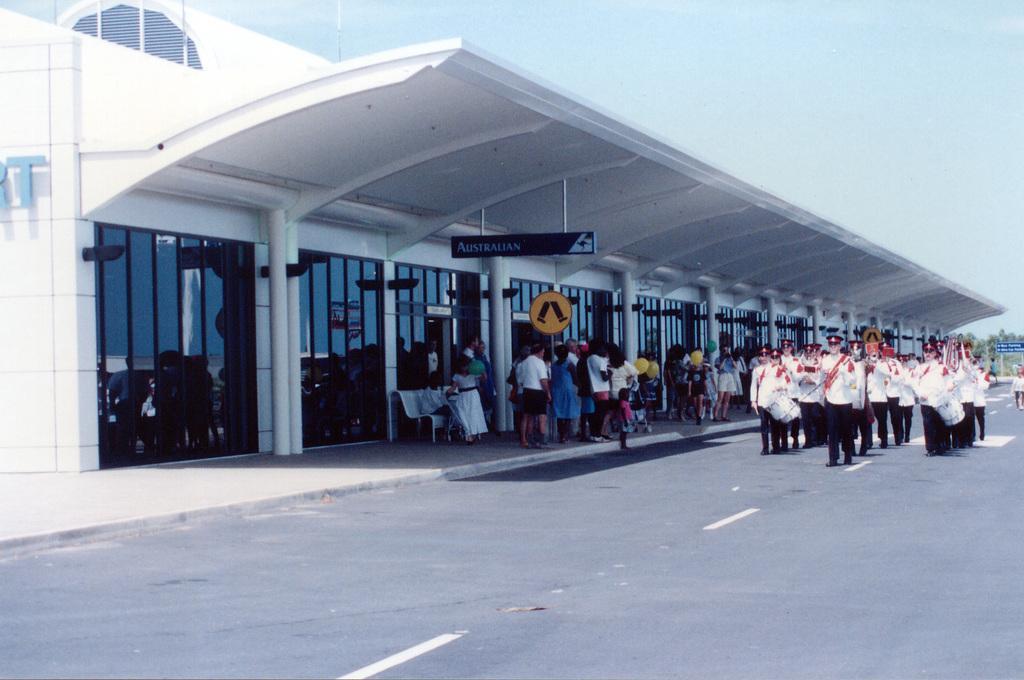Could you give a brief overview of what you see in this image? On the right side, there are persons in white color shirts, walking on the road, on which there are white color lines. Some of these persons are playing musical instruments. Beside this road, there are persons on the platform, which is having a roof attached to a building, which is having glass windows. In the background, there are trees and there are clouds in the sky. 